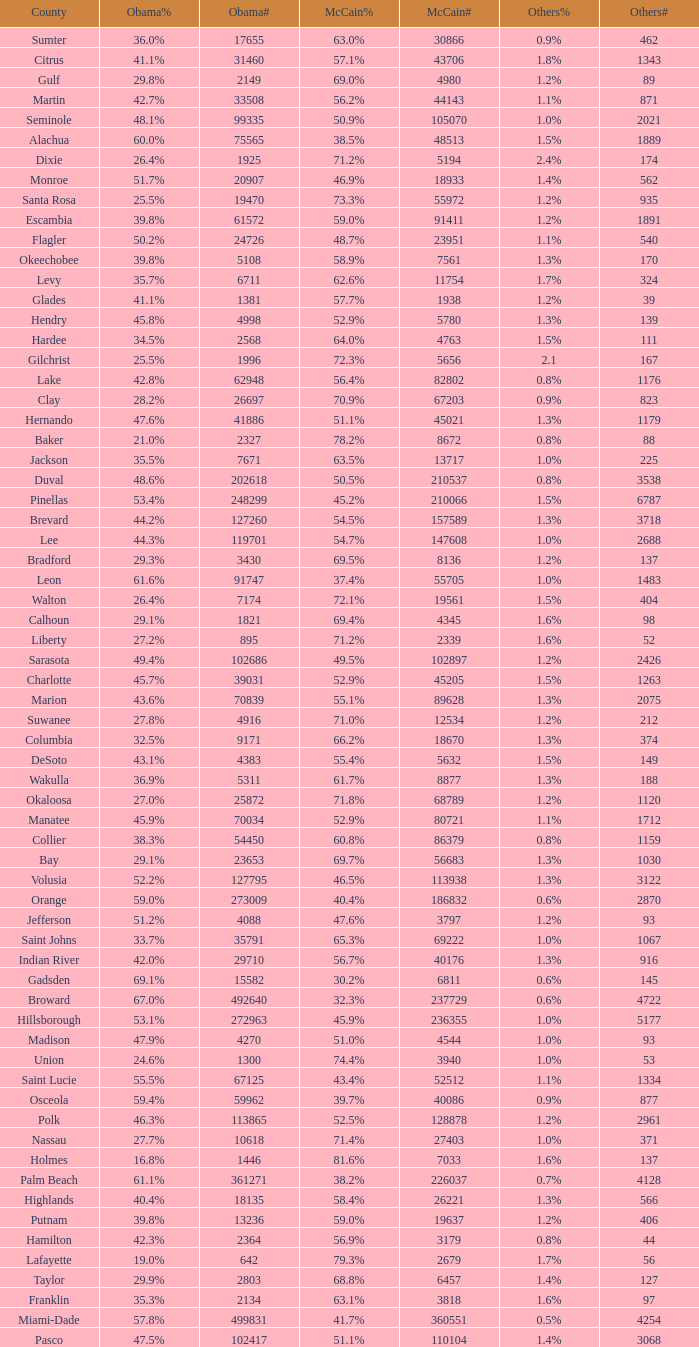What was the number of others votes in Columbia county? 374.0. 